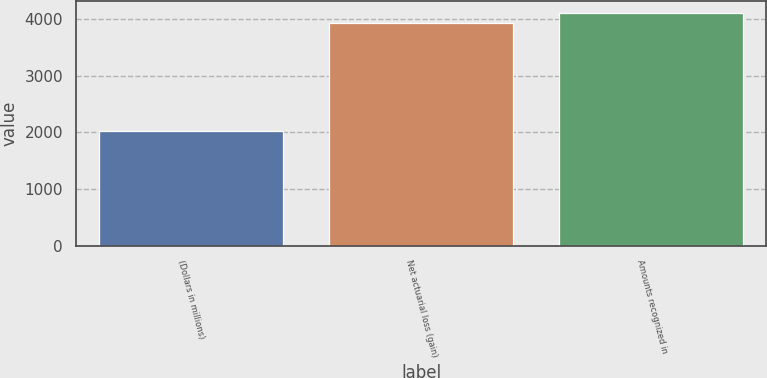<chart> <loc_0><loc_0><loc_500><loc_500><bar_chart><fcel>(Dollars in millions)<fcel>Net actuarial loss (gain)<fcel>Amounts recognized in<nl><fcel>2015<fcel>3920<fcel>4110.5<nl></chart> 